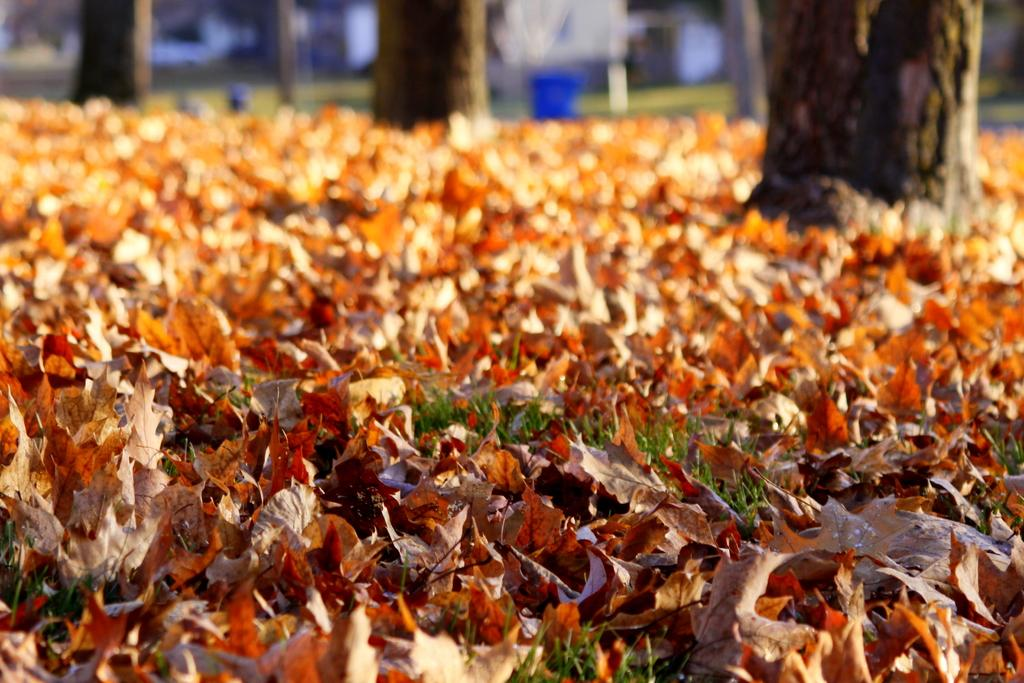What type of vegetation can be seen on the ground in the image? There are dried leaves and grasses on the ground in the image. Can you describe the background of the image? The background is blurred, and there are tree trunks visible. What type of punishment is being administered to the tree in the image? There is no punishment being administered to any tree in the image. What type of board can be seen attached to the tree trunks in the image? There is no board present in the image; only tree trunks are visible in the background. 